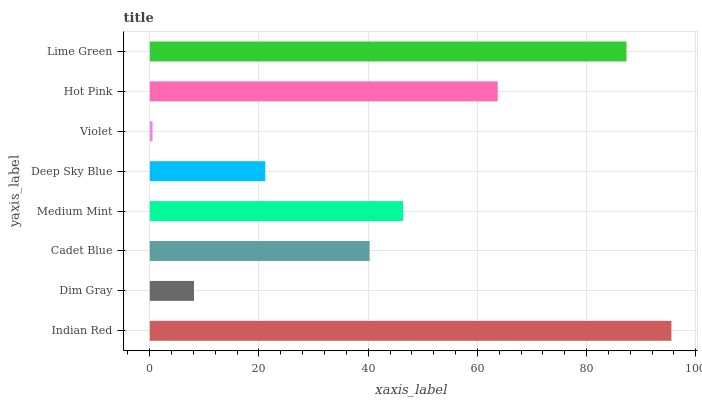Is Violet the minimum?
Answer yes or no. Yes. Is Indian Red the maximum?
Answer yes or no. Yes. Is Dim Gray the minimum?
Answer yes or no. No. Is Dim Gray the maximum?
Answer yes or no. No. Is Indian Red greater than Dim Gray?
Answer yes or no. Yes. Is Dim Gray less than Indian Red?
Answer yes or no. Yes. Is Dim Gray greater than Indian Red?
Answer yes or no. No. Is Indian Red less than Dim Gray?
Answer yes or no. No. Is Medium Mint the high median?
Answer yes or no. Yes. Is Cadet Blue the low median?
Answer yes or no. Yes. Is Lime Green the high median?
Answer yes or no. No. Is Indian Red the low median?
Answer yes or no. No. 